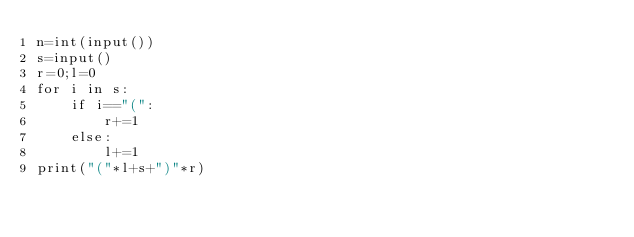Convert code to text. <code><loc_0><loc_0><loc_500><loc_500><_Python_>n=int(input())
s=input()
r=0;l=0
for i in s:
    if i=="(":
        r+=1
    else:
        l+=1
print("("*l+s+")"*r)
</code> 